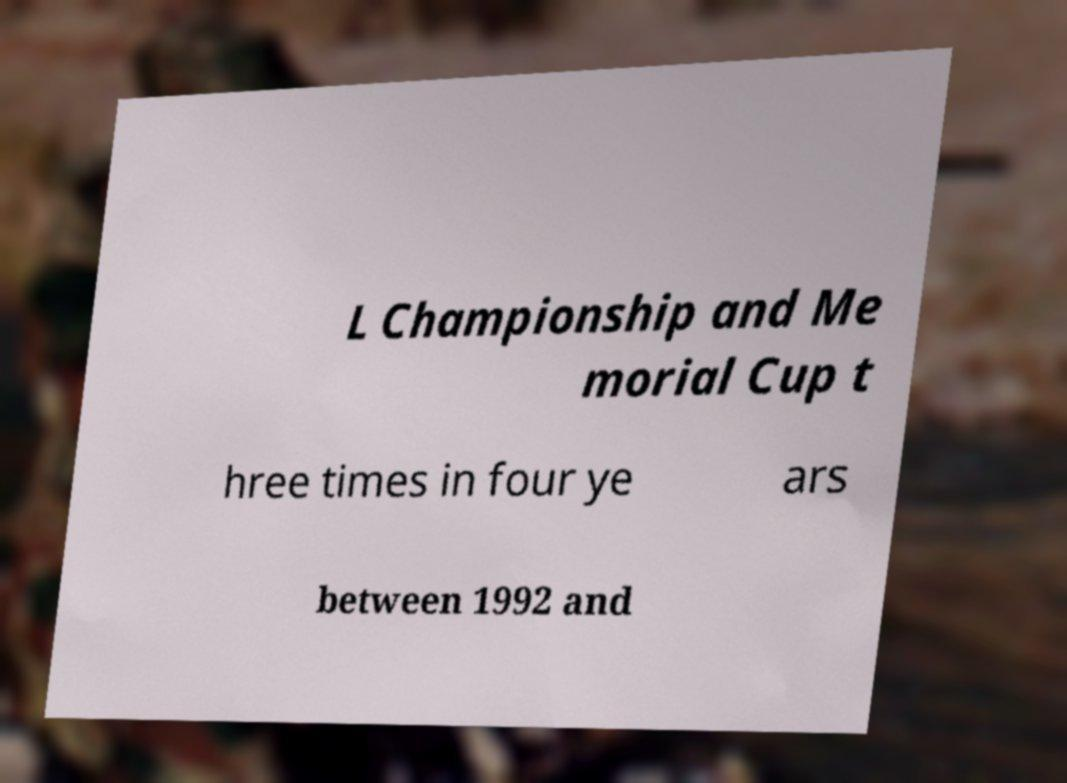There's text embedded in this image that I need extracted. Can you transcribe it verbatim? L Championship and Me morial Cup t hree times in four ye ars between 1992 and 